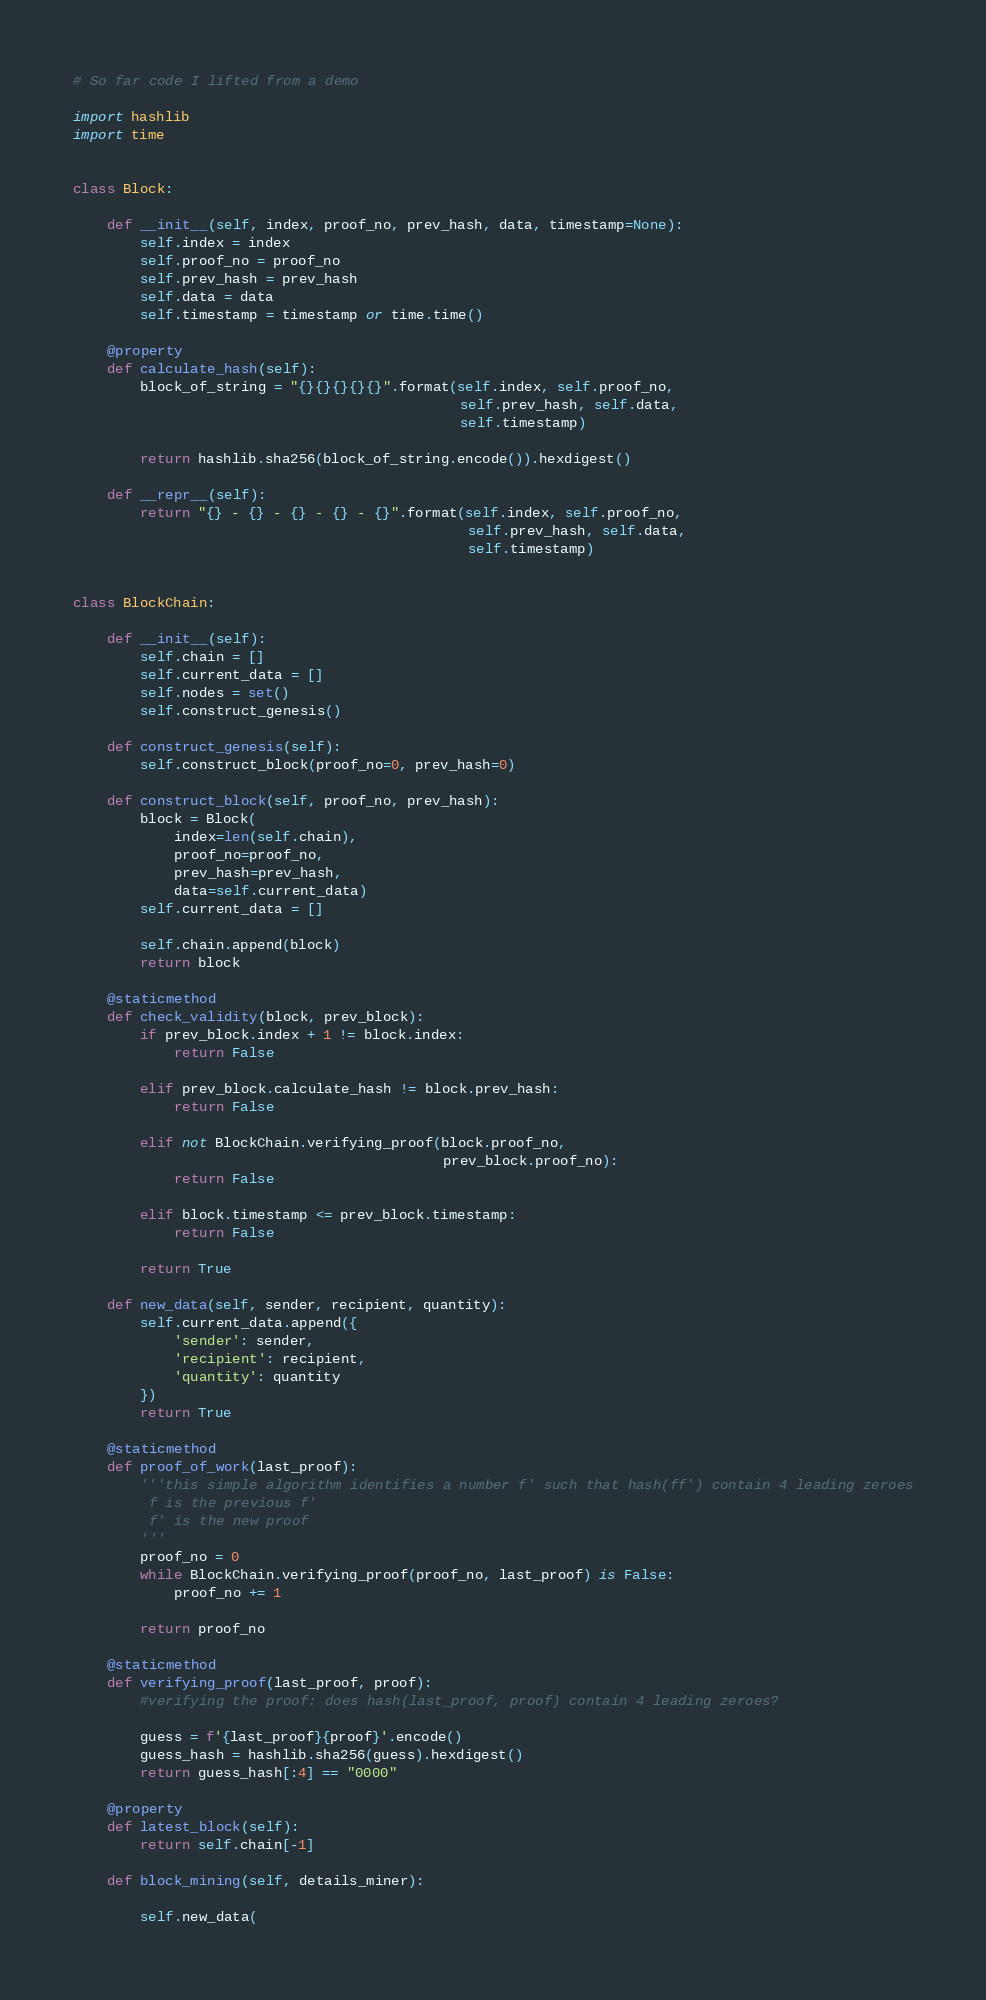<code> <loc_0><loc_0><loc_500><loc_500><_Python_># So far code I lifted from a demo

import hashlib
import time


class Block:

    def __init__(self, index, proof_no, prev_hash, data, timestamp=None):
        self.index = index
        self.proof_no = proof_no
        self.prev_hash = prev_hash
        self.data = data
        self.timestamp = timestamp or time.time()

    @property
    def calculate_hash(self):
        block_of_string = "{}{}{}{}{}".format(self.index, self.proof_no,
                                              self.prev_hash, self.data,
                                              self.timestamp)

        return hashlib.sha256(block_of_string.encode()).hexdigest()

    def __repr__(self):
        return "{} - {} - {} - {} - {}".format(self.index, self.proof_no,
                                               self.prev_hash, self.data,
                                               self.timestamp)


class BlockChain:

    def __init__(self):
        self.chain = []
        self.current_data = []
        self.nodes = set()
        self.construct_genesis()

    def construct_genesis(self):
        self.construct_block(proof_no=0, prev_hash=0)

    def construct_block(self, proof_no, prev_hash):
        block = Block(
            index=len(self.chain),
            proof_no=proof_no,
            prev_hash=prev_hash,
            data=self.current_data)
        self.current_data = []

        self.chain.append(block)
        return block

    @staticmethod
    def check_validity(block, prev_block):
        if prev_block.index + 1 != block.index:
            return False

        elif prev_block.calculate_hash != block.prev_hash:
            return False

        elif not BlockChain.verifying_proof(block.proof_no,
                                            prev_block.proof_no):
            return False

        elif block.timestamp <= prev_block.timestamp:
            return False

        return True

    def new_data(self, sender, recipient, quantity):
        self.current_data.append({
            'sender': sender,
            'recipient': recipient,
            'quantity': quantity
        })
        return True

    @staticmethod
    def proof_of_work(last_proof):
        '''this simple algorithm identifies a number f' such that hash(ff') contain 4 leading zeroes
         f is the previous f'
         f' is the new proof
        '''
        proof_no = 0
        while BlockChain.verifying_proof(proof_no, last_proof) is False:
            proof_no += 1

        return proof_no

    @staticmethod
    def verifying_proof(last_proof, proof):
        #verifying the proof: does hash(last_proof, proof) contain 4 leading zeroes?

        guess = f'{last_proof}{proof}'.encode()
        guess_hash = hashlib.sha256(guess).hexdigest()
        return guess_hash[:4] == "0000"

    @property
    def latest_block(self):
        return self.chain[-1]

    def block_mining(self, details_miner):

        self.new_data(</code> 